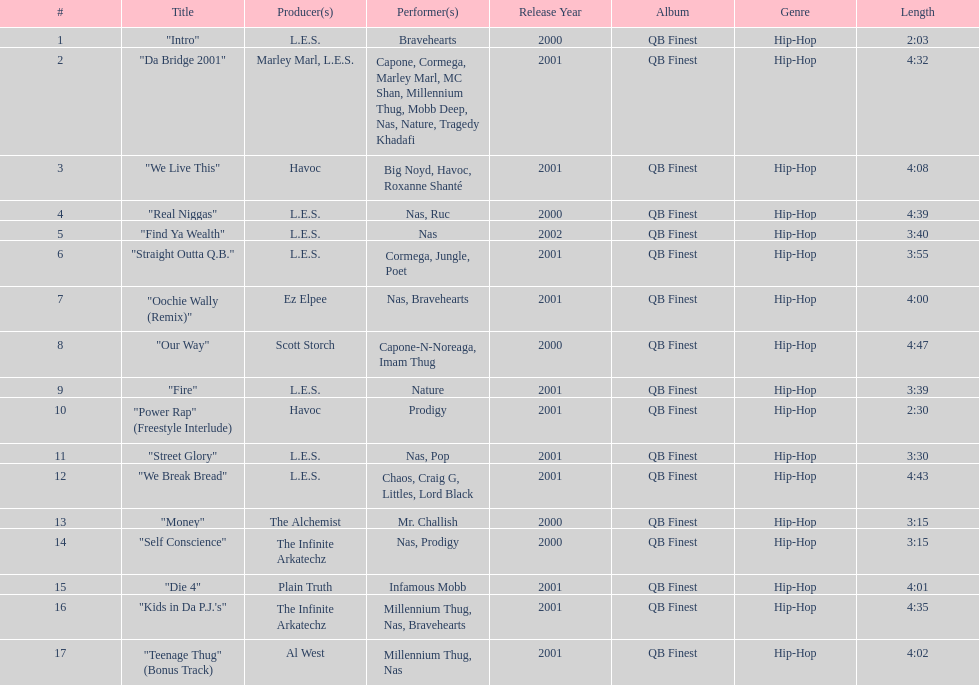Who produced the last track of the album? Al West. Parse the full table. {'header': ['#', 'Title', 'Producer(s)', 'Performer(s)', 'Release Year', 'Album', 'Genre', 'Length'], 'rows': [['1', '"Intro"', 'L.E.S.', 'Bravehearts', '2000', 'QB Finest', 'Hip-Hop', '2:03'], ['2', '"Da Bridge 2001"', 'Marley Marl, L.E.S.', 'Capone, Cormega, Marley Marl, MC Shan, Millennium Thug, Mobb Deep, Nas, Nature, Tragedy Khadafi', '2001', 'QB Finest', 'Hip-Hop', '4:32'], ['3', '"We Live This"', 'Havoc', 'Big Noyd, Havoc, Roxanne Shanté', '2001', 'QB Finest', 'Hip-Hop', '4:08'], ['4', '"Real Niggas"', 'L.E.S.', 'Nas, Ruc', '2000', 'QB Finest', 'Hip-Hop', '4:39'], ['5', '"Find Ya Wealth"', 'L.E.S.', 'Nas', '2002', 'QB Finest', 'Hip-Hop', '3:40'], ['6', '"Straight Outta Q.B."', 'L.E.S.', 'Cormega, Jungle, Poet', '2001', 'QB Finest', 'Hip-Hop', '3:55'], ['7', '"Oochie Wally (Remix)"', 'Ez Elpee', 'Nas, Bravehearts', '2001', 'QB Finest', 'Hip-Hop', '4:00'], ['8', '"Our Way"', 'Scott Storch', 'Capone-N-Noreaga, Imam Thug', '2000', 'QB Finest', 'Hip-Hop', '4:47'], ['9', '"Fire"', 'L.E.S.', 'Nature', '2001', 'QB Finest', 'Hip-Hop', '3:39'], ['10', '"Power Rap" (Freestyle Interlude)', 'Havoc', 'Prodigy', '2001', 'QB Finest', 'Hip-Hop', '2:30'], ['11', '"Street Glory"', 'L.E.S.', 'Nas, Pop', '2001', 'QB Finest', 'Hip-Hop', '3:30'], ['12', '"We Break Bread"', 'L.E.S.', 'Chaos, Craig G, Littles, Lord Black', '2001', 'QB Finest', 'Hip-Hop', '4:43'], ['13', '"Money"', 'The Alchemist', 'Mr. Challish', '2000', 'QB Finest', 'Hip-Hop', '3:15'], ['14', '"Self Conscience"', 'The Infinite Arkatechz', 'Nas, Prodigy', '2000', 'QB Finest', 'Hip-Hop', '3:15'], ['15', '"Die 4"', 'Plain Truth', 'Infamous Mobb', '2001', 'QB Finest', 'Hip-Hop', '4:01'], ['16', '"Kids in Da P.J.\'s"', 'The Infinite Arkatechz', 'Millennium Thug, Nas, Bravehearts', '2001', 'QB Finest', 'Hip-Hop', '4:35'], ['17', '"Teenage Thug" (Bonus Track)', 'Al West', 'Millennium Thug, Nas', '2001', 'QB Finest', 'Hip-Hop', '4:02']]} 